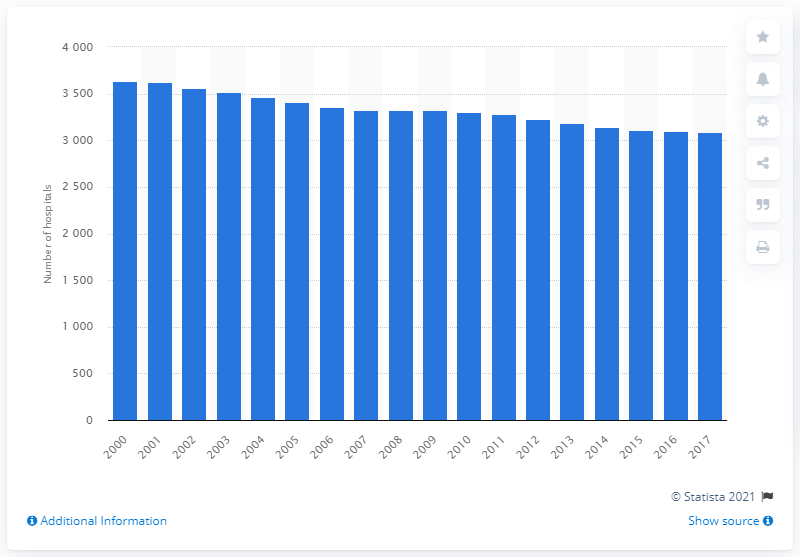Draw attention to some important aspects in this diagram. The number of hospitals in Germany exceeded 3,600 in 2000. 